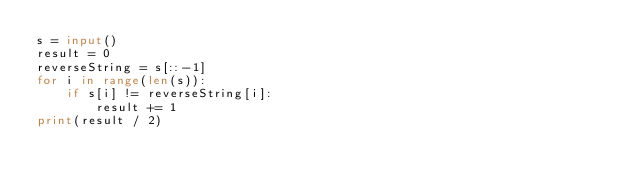Convert code to text. <code><loc_0><loc_0><loc_500><loc_500><_Python_>s = input()
result = 0
reverseString = s[::-1]
for i in range(len(s)):
    if s[i] != reverseString[i]:
        result += 1
print(result / 2)
</code> 